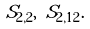<formula> <loc_0><loc_0><loc_500><loc_500>S _ { 2 , 2 } , \ S _ { 2 , 1 2 } .</formula> 